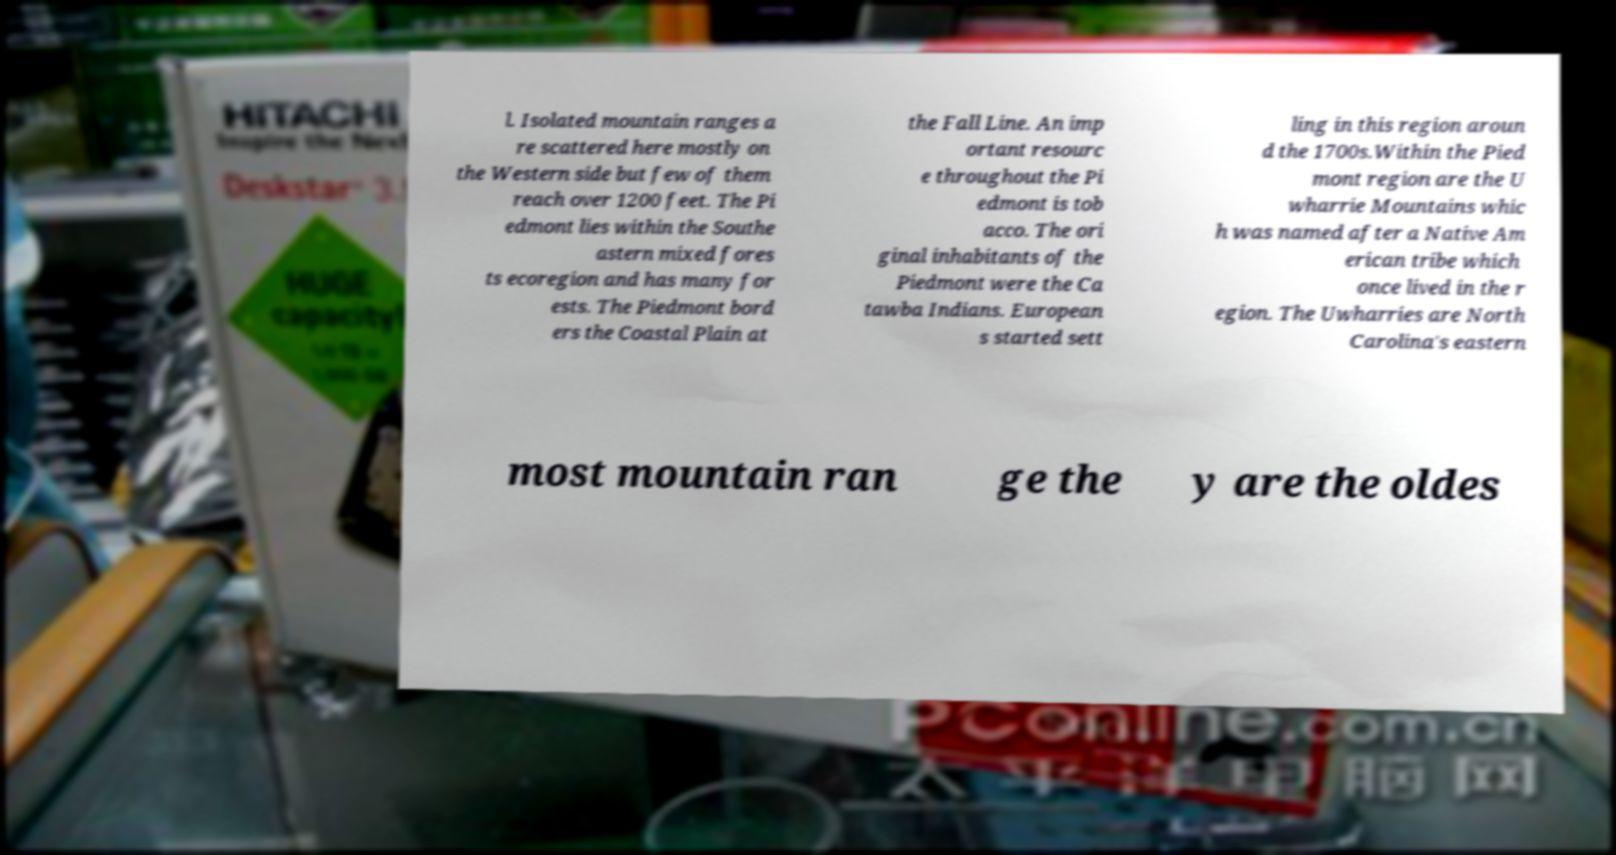For documentation purposes, I need the text within this image transcribed. Could you provide that? l. Isolated mountain ranges a re scattered here mostly on the Western side but few of them reach over 1200 feet. The Pi edmont lies within the Southe astern mixed fores ts ecoregion and has many for ests. The Piedmont bord ers the Coastal Plain at the Fall Line. An imp ortant resourc e throughout the Pi edmont is tob acco. The ori ginal inhabitants of the Piedmont were the Ca tawba Indians. European s started sett ling in this region aroun d the 1700s.Within the Pied mont region are the U wharrie Mountains whic h was named after a Native Am erican tribe which once lived in the r egion. The Uwharries are North Carolina's eastern most mountain ran ge the y are the oldes 